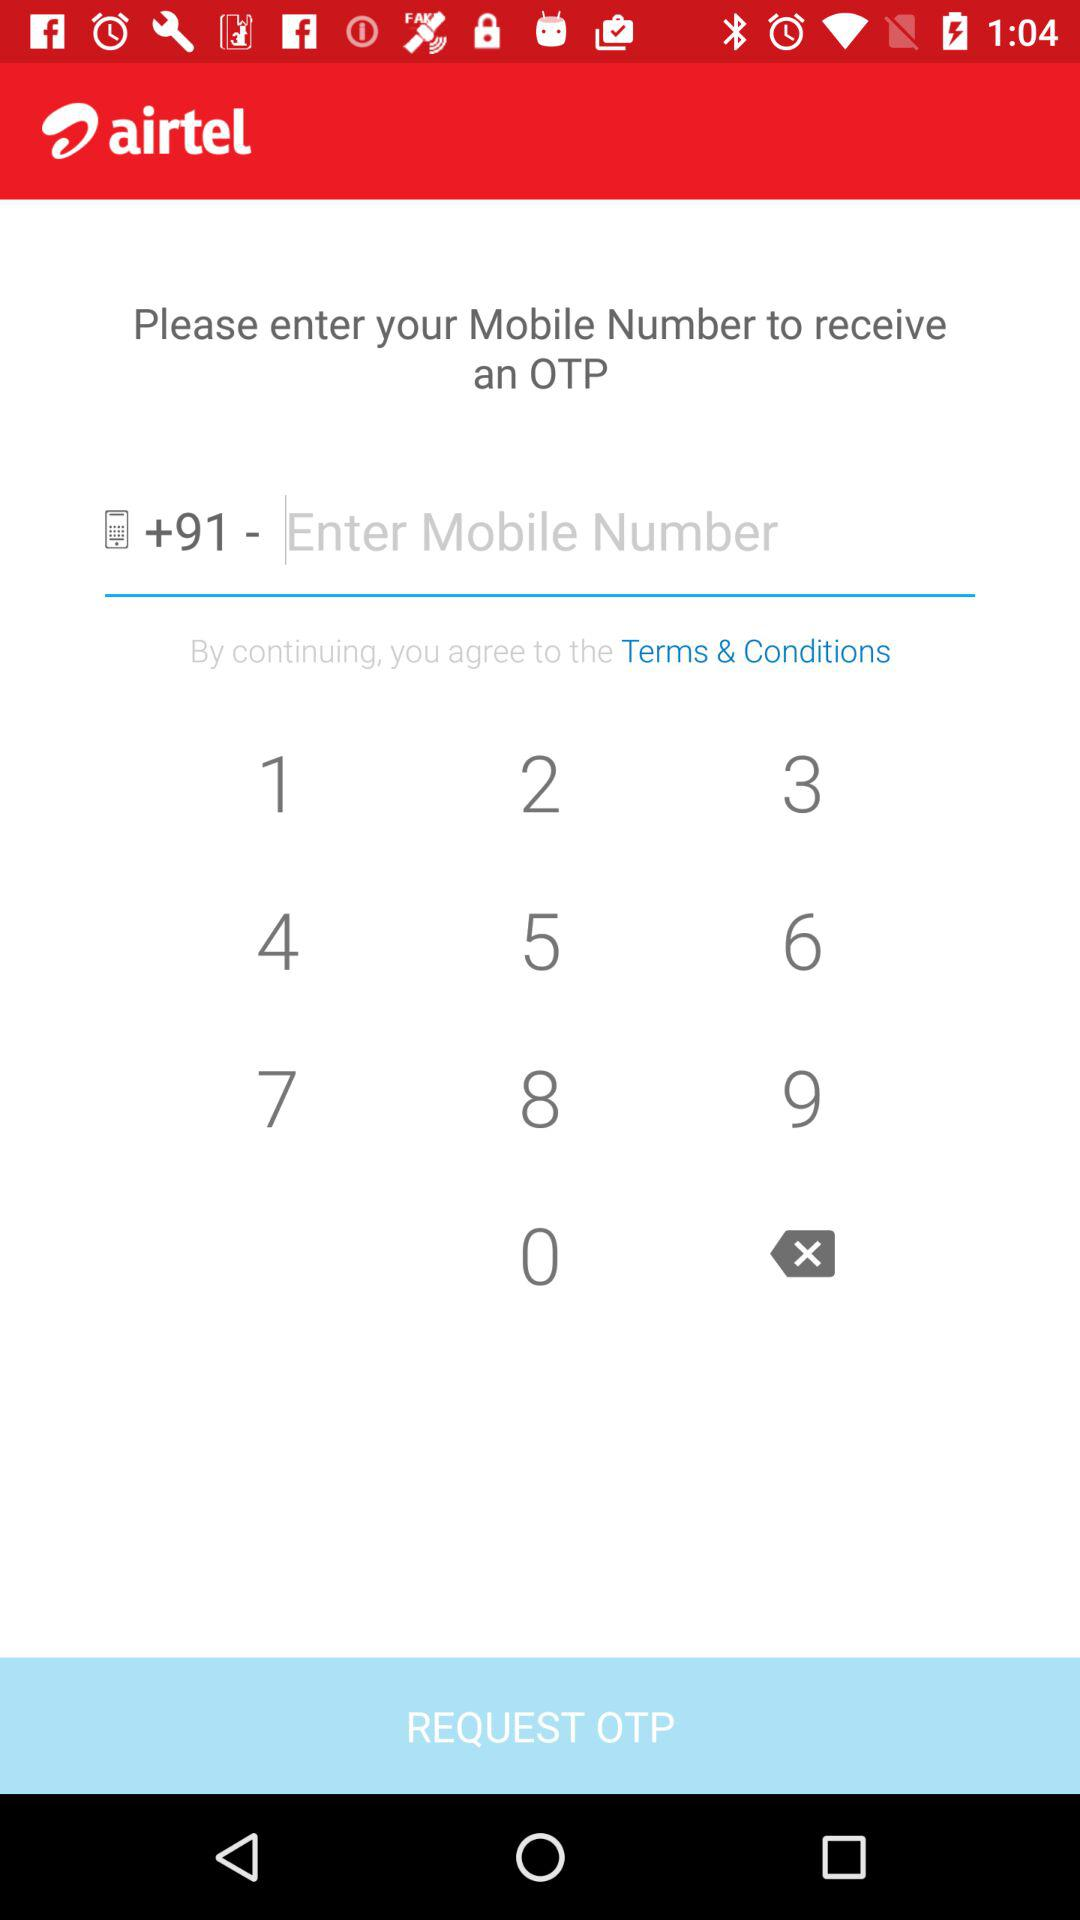What is the country code? The country code is +91. 